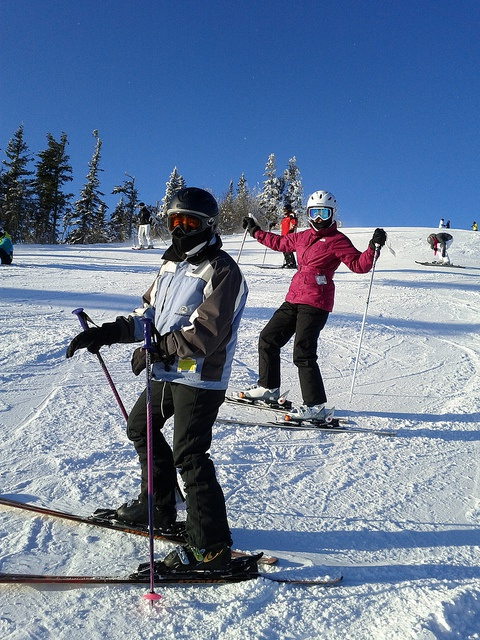Describe the objects in this image and their specific colors. I can see people in blue, black, lightgray, gray, and darkgray tones, people in blue, black, maroon, brown, and lightgray tones, skis in blue, black, gray, maroon, and darkgray tones, skis in blue, gray, darkgray, and black tones, and people in blue, black, red, gray, and darkgray tones in this image. 